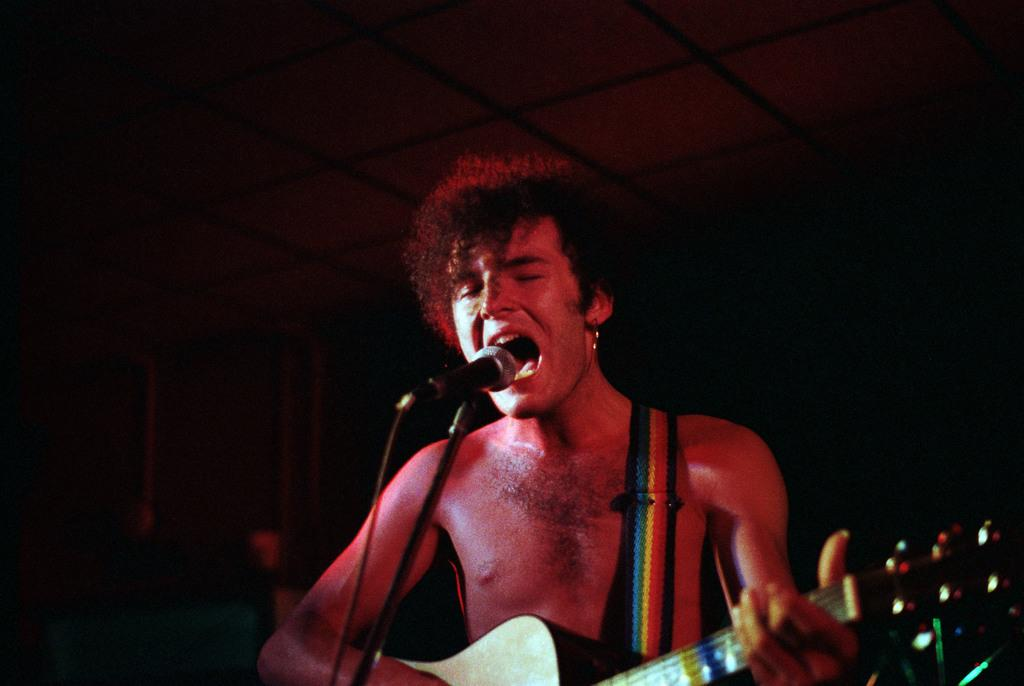What is the main subject of the image? There is a person in the image. What is the person doing in the image? The person is standing and singing. What instrument is the person holding in the image? The person is holding a guitar. What equipment is present for amplifying the person's voice in the image? There is a microphone and a microphone stand in the image. What type of feast is being prepared in the image? There is no indication of a feast being prepared in the image; it features a person singing with a guitar and microphone. How does the room's acoustics affect the person's singing in the image? The provided facts do not mention any details about the room's acoustics, so it cannot be determined from the image. 